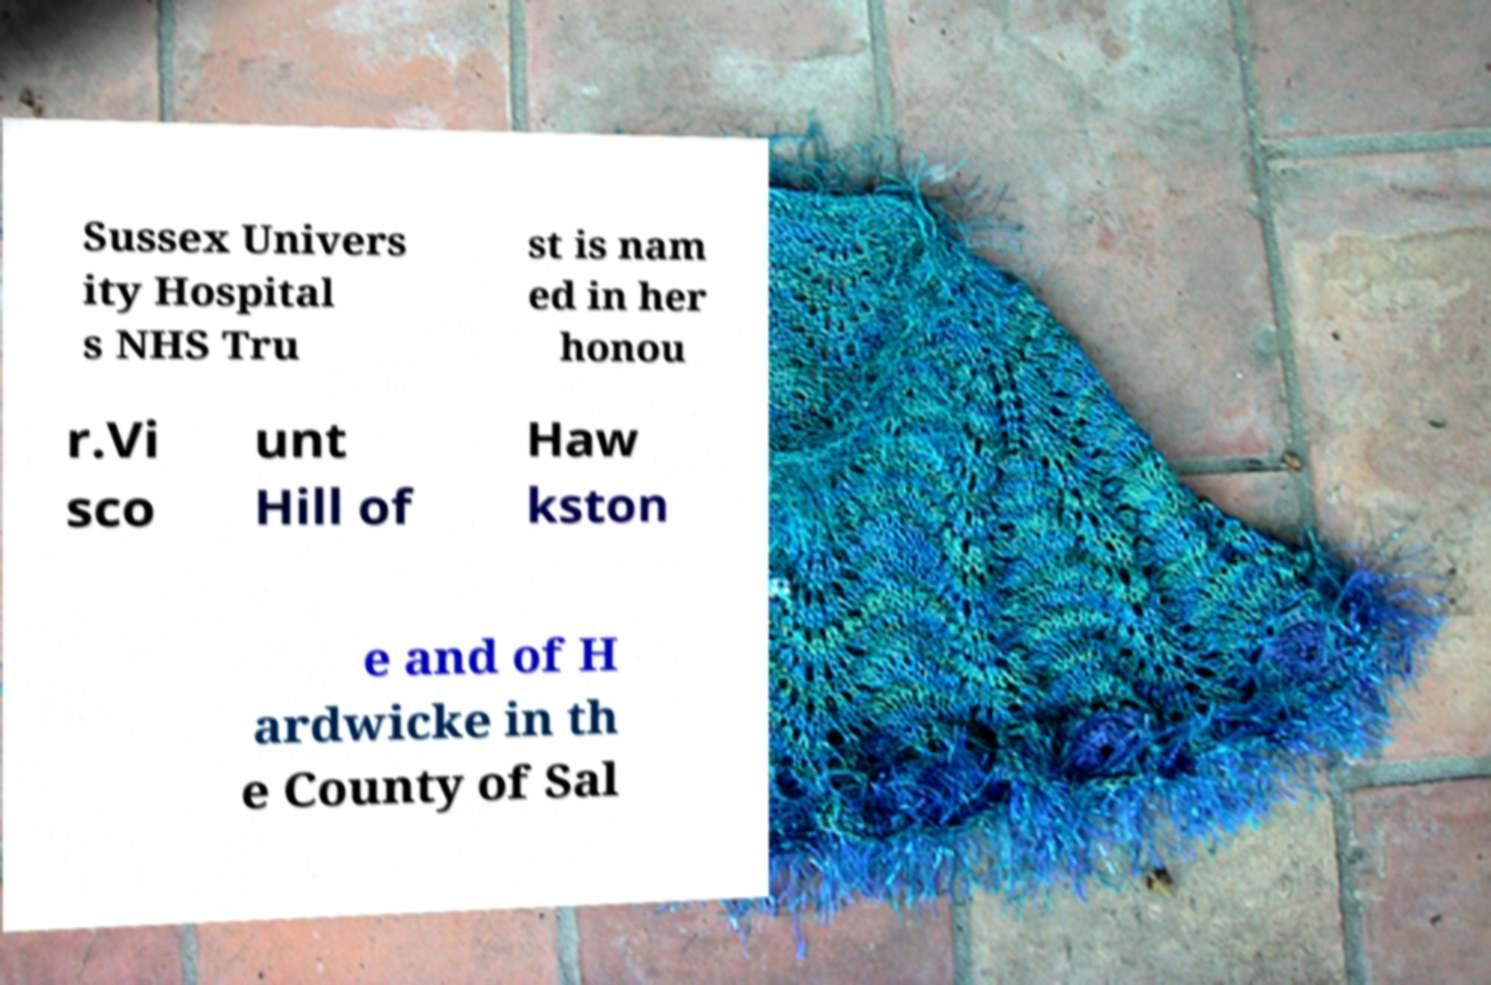There's text embedded in this image that I need extracted. Can you transcribe it verbatim? Sussex Univers ity Hospital s NHS Tru st is nam ed in her honou r.Vi sco unt Hill of Haw kston e and of H ardwicke in th e County of Sal 